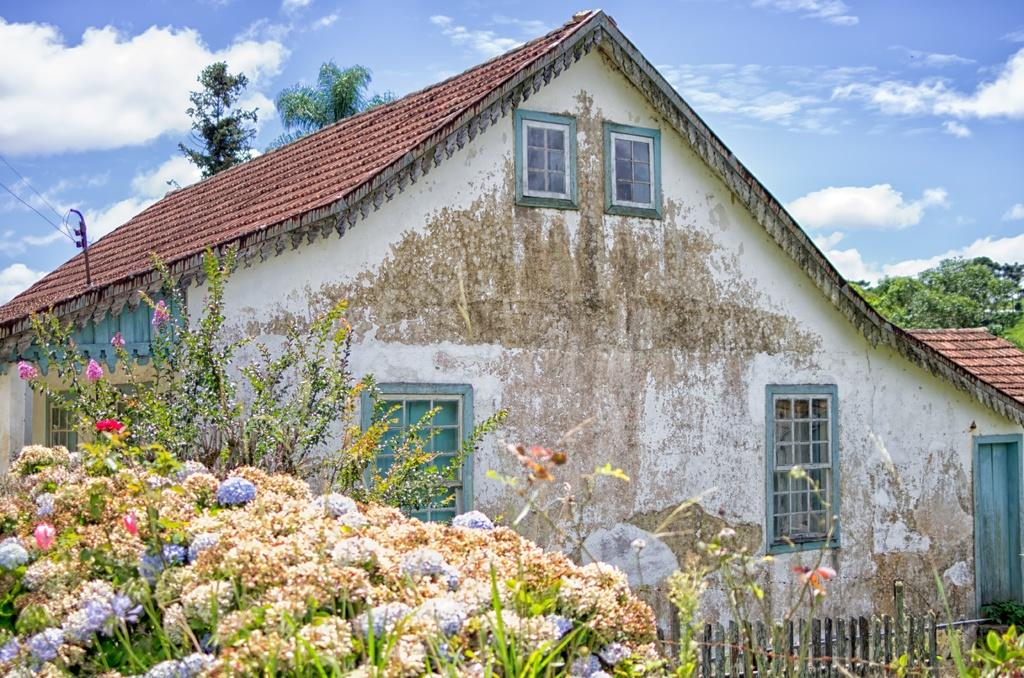What is the main subject of the image? The main subject of the image is a house. What can be seen on the left side of the house? There are flower plants on the left side of the house. How would you describe the weather in the image? The sky is sunny in the image, suggesting a clear and bright day. What type of stomach pain is the house experiencing in the image? There is no indication of any stomach pain or discomfort in the image, as it features a house with flower plants and a sunny sky. 